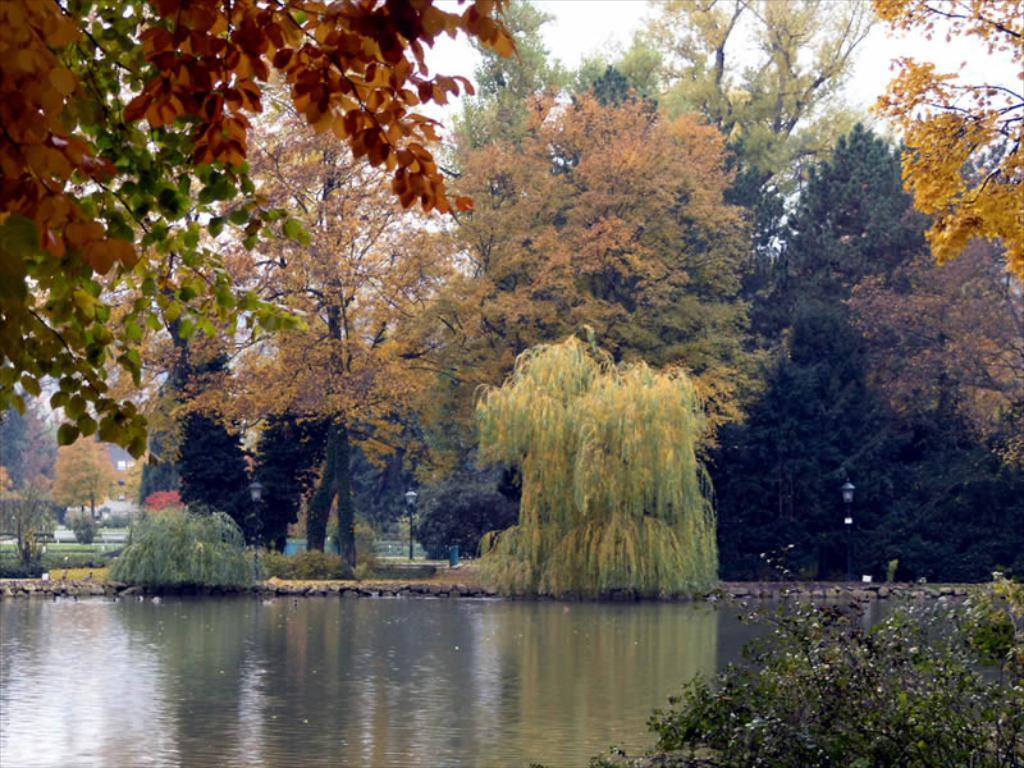What is the primary element visible in the image? There is water in the image. What can be seen near the water? There are plants and poles near the water. What type of vegetation is present in the image? There are many trees in the image. What is visible in the background of the image? The sky is visible in the background of the image. What type of hammer can be seen being used by the trees in the image? There is no hammer present in the image, and trees do not use hammers. 